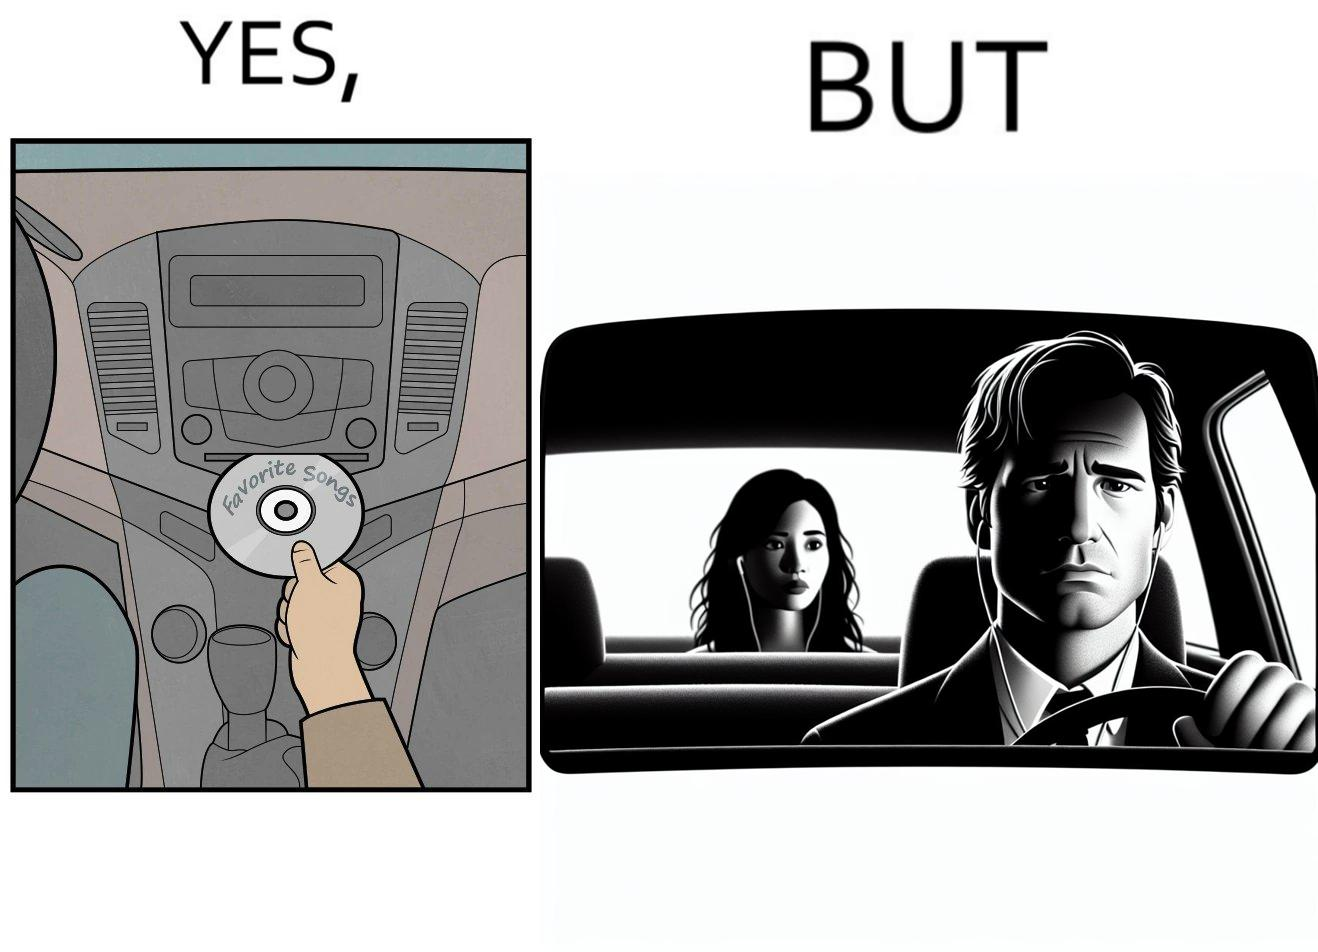What does this image depict? The image is funny, as the driver of the car inserts a CD named "Favorite Songs" into the CD player for the passenger, but the driver is sad on seeing the passenger in the back seat listening to something else on earphones instead. 